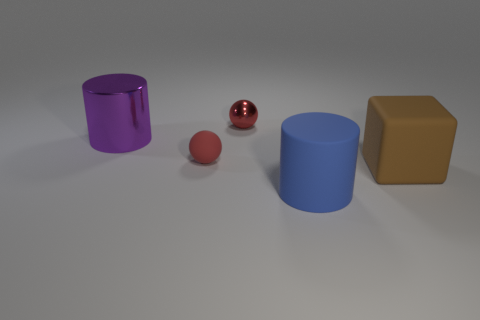How many objects are large rubber things or metal cylinders?
Ensure brevity in your answer.  3. Are any big purple cylinders visible?
Your response must be concise. Yes. There is a large object that is to the left of the small thing that is on the right side of the sphere left of the red shiny ball; what is its material?
Offer a terse response. Metal. Are there fewer big purple metal objects behind the metallic ball than brown metal blocks?
Your response must be concise. No. There is a brown object that is the same size as the metal cylinder; what is it made of?
Ensure brevity in your answer.  Rubber. How big is the object that is right of the small rubber thing and left of the big matte cylinder?
Provide a short and direct response. Small. There is another red object that is the same shape as the red metallic thing; what size is it?
Your answer should be very brief. Small. How many objects are either purple objects or things left of the big block?
Give a very brief answer. 4. The purple thing is what shape?
Ensure brevity in your answer.  Cylinder. The small thing behind the small sphere in front of the metal cylinder is what shape?
Offer a very short reply. Sphere. 